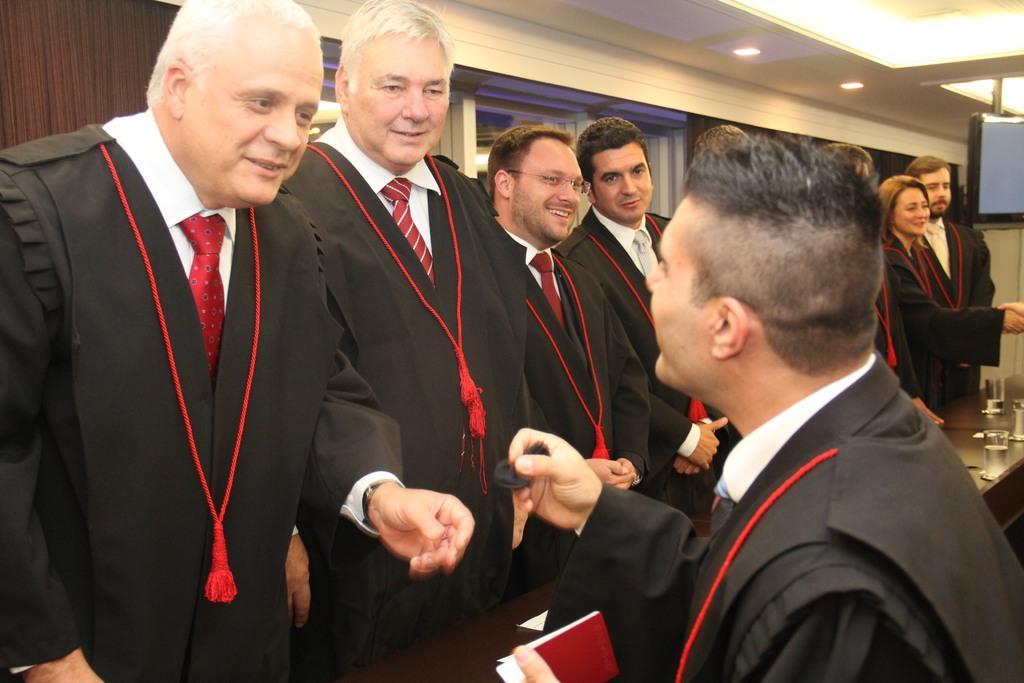Please provide a concise description of this image. In this image we can see group of persons standing at the table. On the table we can see water in glasses. In the background we can see wall, lights, television and windows. 